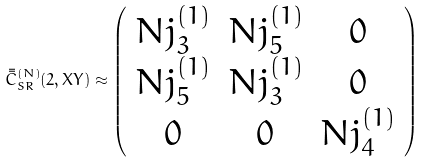Convert formula to latex. <formula><loc_0><loc_0><loc_500><loc_500>\bar { \bar { C } } _ { S R } ^ { ( N ) } ( 2 , X Y ) \approx \left ( \begin{array} { c c c } N j _ { 3 } ^ { ( 1 ) } & N j _ { 5 } ^ { ( 1 ) } & 0 \\ N j _ { 5 } ^ { ( 1 ) } & N j _ { 3 } ^ { ( 1 ) } & 0 \\ 0 & 0 & N j _ { 4 } ^ { ( 1 ) } \end{array} \right )</formula> 